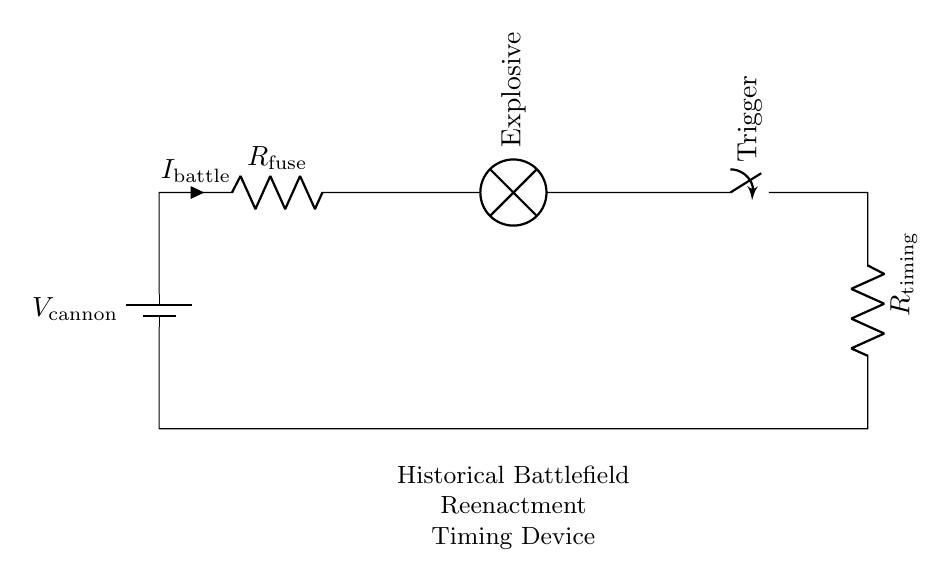What is the main power source in the circuit? The main power source is the battery labeled as V_cannon, which provides the necessary voltage to the circuit.
Answer: V_cannon What component indicates the current flow during a battle? The component indicating the current flow is labeled as R_fuse, which shows the direction of the current passing through it.
Answer: R_fuse What does the lamp represent in this circuit? The lamp in the circuit represents the explosive mechanism, which is triggered when the circuit is completed through the switch.
Answer: Explosive What happens when the trigger switch is closed? When the trigger switch is closed, the circuit is completed allowing current to flow, which activates the lamp and initiates the explosive.
Answer: Activates the explosive What type of circuit is represented by this diagram? The circuit represented is a series circuit because all components are connected end-to-end, and current flows through each component sequentially.
Answer: Series circuit How many resistors are present in the circuit? There are two resistors in the circuit: one labeled R_fuse and the other labeled R_timing, indicating their separate roles in the circuit.
Answer: Two What is the role of the R_timing resistor in this circuit? The R_timing resistor likely plays a role in controlling the timing of the circuit's response, affecting how quickly the lamp (explosive) is activated.
Answer: Timing control 